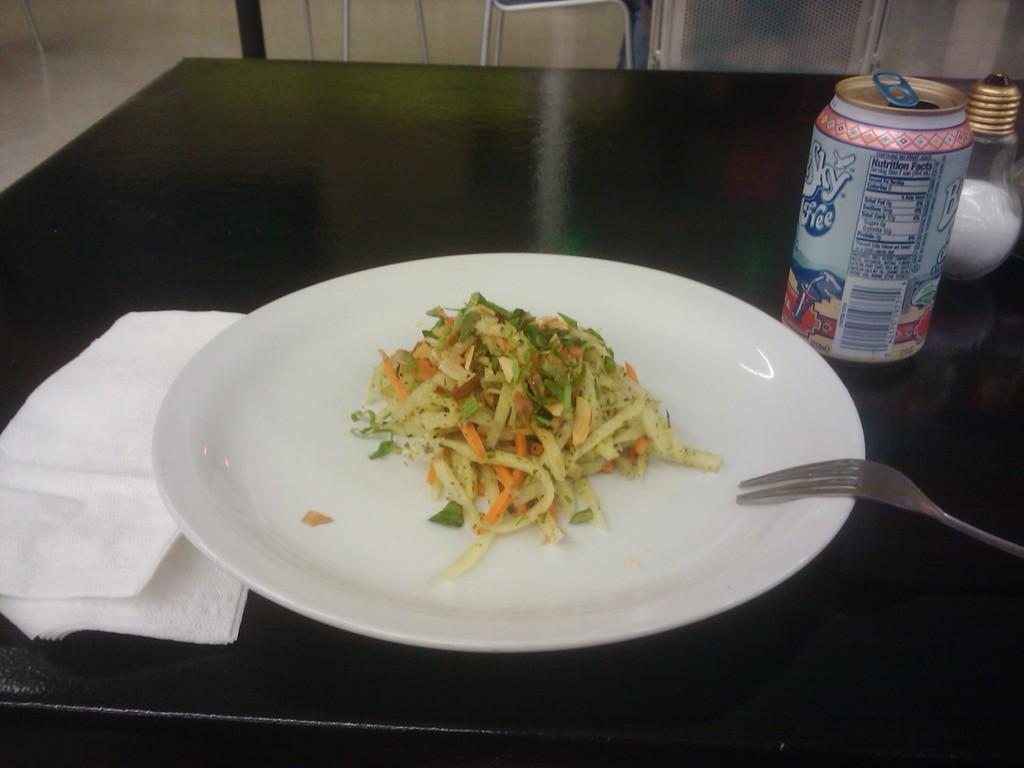What piece of furniture is present in the image? There is a table in the image. What type of container is on the table? There is a beverage tin on the table. What condiment container is on the table? There is a salt container on the table. What is on the serving plate on the table? There is food on the serving plate on the table. What utensil is on the table? There is a fork on the table. What item is used for wiping or cleaning on the table? There is a paper napkin on the table. What is the view from the window in the image? There is no window present in the image, so it is not possible to describe a view from a window. 